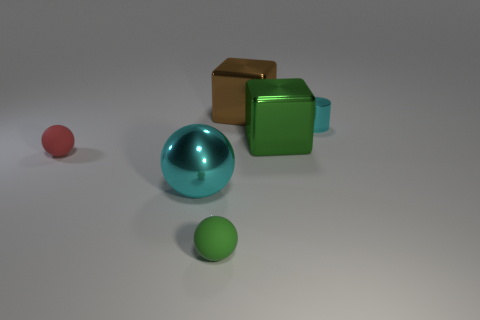Subtract all shiny spheres. How many spheres are left? 2 Add 2 cyan metal cylinders. How many objects exist? 8 Subtract all brown blocks. How many blocks are left? 1 Subtract 0 green cylinders. How many objects are left? 6 Subtract all cylinders. How many objects are left? 5 Subtract all purple cubes. Subtract all green cylinders. How many cubes are left? 2 Subtract all brown blocks. Subtract all brown shiny cylinders. How many objects are left? 5 Add 3 small matte objects. How many small matte objects are left? 5 Add 3 brown metallic cylinders. How many brown metallic cylinders exist? 3 